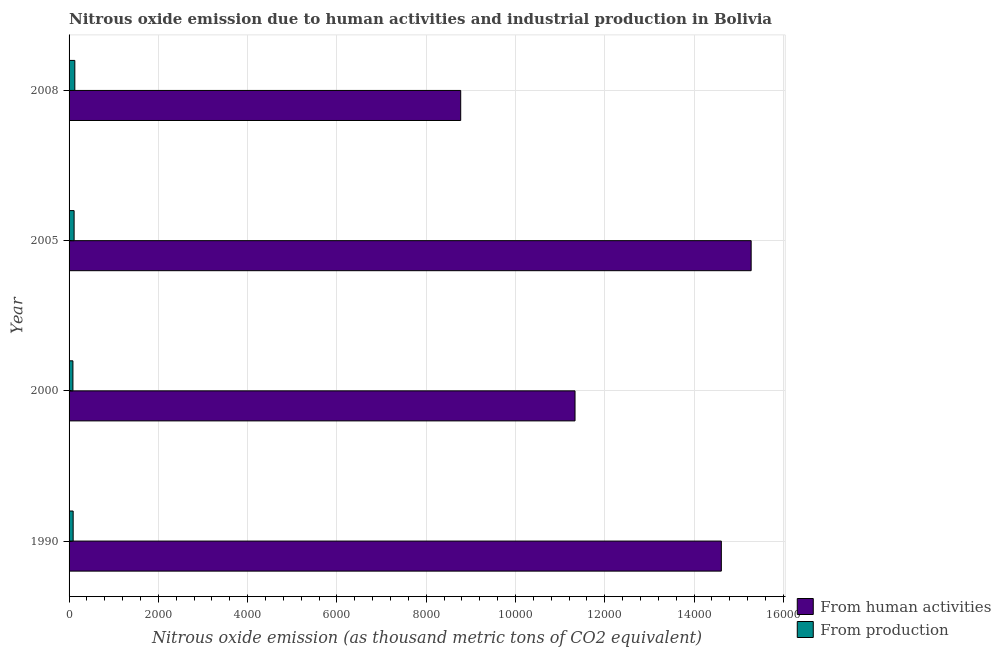How many groups of bars are there?
Give a very brief answer. 4. How many bars are there on the 2nd tick from the top?
Your answer should be compact. 2. What is the label of the 2nd group of bars from the top?
Your response must be concise. 2005. What is the amount of emissions generated from industries in 2008?
Ensure brevity in your answer.  128.9. Across all years, what is the maximum amount of emissions from human activities?
Give a very brief answer. 1.53e+04. Across all years, what is the minimum amount of emissions from human activities?
Provide a succinct answer. 8773. In which year was the amount of emissions generated from industries maximum?
Offer a terse response. 2008. In which year was the amount of emissions from human activities minimum?
Provide a succinct answer. 2008. What is the total amount of emissions from human activities in the graph?
Make the answer very short. 5.00e+04. What is the difference between the amount of emissions from human activities in 2000 and that in 2008?
Your answer should be very brief. 2561.1. What is the difference between the amount of emissions from human activities in 2008 and the amount of emissions generated from industries in 1990?
Offer a very short reply. 8681.6. What is the average amount of emissions from human activities per year?
Keep it short and to the point. 1.25e+04. In the year 2005, what is the difference between the amount of emissions from human activities and amount of emissions generated from industries?
Ensure brevity in your answer.  1.52e+04. In how many years, is the amount of emissions generated from industries greater than 14000 thousand metric tons?
Ensure brevity in your answer.  0. What is the ratio of the amount of emissions from human activities in 1990 to that in 2005?
Make the answer very short. 0.96. Is the difference between the amount of emissions from human activities in 2000 and 2005 greater than the difference between the amount of emissions generated from industries in 2000 and 2005?
Provide a succinct answer. No. What is the difference between the highest and the second highest amount of emissions generated from industries?
Ensure brevity in your answer.  16.2. What is the difference between the highest and the lowest amount of emissions from human activities?
Your answer should be very brief. 6506.5. In how many years, is the amount of emissions generated from industries greater than the average amount of emissions generated from industries taken over all years?
Ensure brevity in your answer.  2. Is the sum of the amount of emissions from human activities in 2000 and 2008 greater than the maximum amount of emissions generated from industries across all years?
Offer a terse response. Yes. What does the 2nd bar from the top in 2008 represents?
Provide a succinct answer. From human activities. What does the 1st bar from the bottom in 2000 represents?
Give a very brief answer. From human activities. Does the graph contain any zero values?
Give a very brief answer. No. What is the title of the graph?
Provide a succinct answer. Nitrous oxide emission due to human activities and industrial production in Bolivia. What is the label or title of the X-axis?
Offer a terse response. Nitrous oxide emission (as thousand metric tons of CO2 equivalent). What is the label or title of the Y-axis?
Offer a very short reply. Year. What is the Nitrous oxide emission (as thousand metric tons of CO2 equivalent) of From human activities in 1990?
Provide a succinct answer. 1.46e+04. What is the Nitrous oxide emission (as thousand metric tons of CO2 equivalent) of From production in 1990?
Offer a very short reply. 91.4. What is the Nitrous oxide emission (as thousand metric tons of CO2 equivalent) of From human activities in 2000?
Offer a very short reply. 1.13e+04. What is the Nitrous oxide emission (as thousand metric tons of CO2 equivalent) in From production in 2000?
Ensure brevity in your answer.  86.3. What is the Nitrous oxide emission (as thousand metric tons of CO2 equivalent) of From human activities in 2005?
Offer a very short reply. 1.53e+04. What is the Nitrous oxide emission (as thousand metric tons of CO2 equivalent) of From production in 2005?
Your response must be concise. 112.7. What is the Nitrous oxide emission (as thousand metric tons of CO2 equivalent) in From human activities in 2008?
Ensure brevity in your answer.  8773. What is the Nitrous oxide emission (as thousand metric tons of CO2 equivalent) in From production in 2008?
Your response must be concise. 128.9. Across all years, what is the maximum Nitrous oxide emission (as thousand metric tons of CO2 equivalent) in From human activities?
Your answer should be very brief. 1.53e+04. Across all years, what is the maximum Nitrous oxide emission (as thousand metric tons of CO2 equivalent) in From production?
Make the answer very short. 128.9. Across all years, what is the minimum Nitrous oxide emission (as thousand metric tons of CO2 equivalent) of From human activities?
Give a very brief answer. 8773. Across all years, what is the minimum Nitrous oxide emission (as thousand metric tons of CO2 equivalent) in From production?
Provide a succinct answer. 86.3. What is the total Nitrous oxide emission (as thousand metric tons of CO2 equivalent) of From human activities in the graph?
Provide a succinct answer. 5.00e+04. What is the total Nitrous oxide emission (as thousand metric tons of CO2 equivalent) of From production in the graph?
Offer a very short reply. 419.3. What is the difference between the Nitrous oxide emission (as thousand metric tons of CO2 equivalent) of From human activities in 1990 and that in 2000?
Keep it short and to the point. 3277.5. What is the difference between the Nitrous oxide emission (as thousand metric tons of CO2 equivalent) in From production in 1990 and that in 2000?
Keep it short and to the point. 5.1. What is the difference between the Nitrous oxide emission (as thousand metric tons of CO2 equivalent) of From human activities in 1990 and that in 2005?
Ensure brevity in your answer.  -667.9. What is the difference between the Nitrous oxide emission (as thousand metric tons of CO2 equivalent) of From production in 1990 and that in 2005?
Your answer should be very brief. -21.3. What is the difference between the Nitrous oxide emission (as thousand metric tons of CO2 equivalent) of From human activities in 1990 and that in 2008?
Your response must be concise. 5838.6. What is the difference between the Nitrous oxide emission (as thousand metric tons of CO2 equivalent) of From production in 1990 and that in 2008?
Give a very brief answer. -37.5. What is the difference between the Nitrous oxide emission (as thousand metric tons of CO2 equivalent) in From human activities in 2000 and that in 2005?
Your response must be concise. -3945.4. What is the difference between the Nitrous oxide emission (as thousand metric tons of CO2 equivalent) of From production in 2000 and that in 2005?
Provide a short and direct response. -26.4. What is the difference between the Nitrous oxide emission (as thousand metric tons of CO2 equivalent) of From human activities in 2000 and that in 2008?
Provide a succinct answer. 2561.1. What is the difference between the Nitrous oxide emission (as thousand metric tons of CO2 equivalent) of From production in 2000 and that in 2008?
Offer a very short reply. -42.6. What is the difference between the Nitrous oxide emission (as thousand metric tons of CO2 equivalent) in From human activities in 2005 and that in 2008?
Ensure brevity in your answer.  6506.5. What is the difference between the Nitrous oxide emission (as thousand metric tons of CO2 equivalent) in From production in 2005 and that in 2008?
Your response must be concise. -16.2. What is the difference between the Nitrous oxide emission (as thousand metric tons of CO2 equivalent) of From human activities in 1990 and the Nitrous oxide emission (as thousand metric tons of CO2 equivalent) of From production in 2000?
Offer a very short reply. 1.45e+04. What is the difference between the Nitrous oxide emission (as thousand metric tons of CO2 equivalent) in From human activities in 1990 and the Nitrous oxide emission (as thousand metric tons of CO2 equivalent) in From production in 2005?
Your answer should be very brief. 1.45e+04. What is the difference between the Nitrous oxide emission (as thousand metric tons of CO2 equivalent) of From human activities in 1990 and the Nitrous oxide emission (as thousand metric tons of CO2 equivalent) of From production in 2008?
Offer a very short reply. 1.45e+04. What is the difference between the Nitrous oxide emission (as thousand metric tons of CO2 equivalent) of From human activities in 2000 and the Nitrous oxide emission (as thousand metric tons of CO2 equivalent) of From production in 2005?
Keep it short and to the point. 1.12e+04. What is the difference between the Nitrous oxide emission (as thousand metric tons of CO2 equivalent) of From human activities in 2000 and the Nitrous oxide emission (as thousand metric tons of CO2 equivalent) of From production in 2008?
Offer a very short reply. 1.12e+04. What is the difference between the Nitrous oxide emission (as thousand metric tons of CO2 equivalent) of From human activities in 2005 and the Nitrous oxide emission (as thousand metric tons of CO2 equivalent) of From production in 2008?
Your answer should be very brief. 1.52e+04. What is the average Nitrous oxide emission (as thousand metric tons of CO2 equivalent) in From human activities per year?
Offer a terse response. 1.25e+04. What is the average Nitrous oxide emission (as thousand metric tons of CO2 equivalent) of From production per year?
Provide a succinct answer. 104.83. In the year 1990, what is the difference between the Nitrous oxide emission (as thousand metric tons of CO2 equivalent) in From human activities and Nitrous oxide emission (as thousand metric tons of CO2 equivalent) in From production?
Offer a very short reply. 1.45e+04. In the year 2000, what is the difference between the Nitrous oxide emission (as thousand metric tons of CO2 equivalent) in From human activities and Nitrous oxide emission (as thousand metric tons of CO2 equivalent) in From production?
Your answer should be compact. 1.12e+04. In the year 2005, what is the difference between the Nitrous oxide emission (as thousand metric tons of CO2 equivalent) in From human activities and Nitrous oxide emission (as thousand metric tons of CO2 equivalent) in From production?
Ensure brevity in your answer.  1.52e+04. In the year 2008, what is the difference between the Nitrous oxide emission (as thousand metric tons of CO2 equivalent) in From human activities and Nitrous oxide emission (as thousand metric tons of CO2 equivalent) in From production?
Provide a succinct answer. 8644.1. What is the ratio of the Nitrous oxide emission (as thousand metric tons of CO2 equivalent) of From human activities in 1990 to that in 2000?
Offer a very short reply. 1.29. What is the ratio of the Nitrous oxide emission (as thousand metric tons of CO2 equivalent) in From production in 1990 to that in 2000?
Keep it short and to the point. 1.06. What is the ratio of the Nitrous oxide emission (as thousand metric tons of CO2 equivalent) in From human activities in 1990 to that in 2005?
Your answer should be compact. 0.96. What is the ratio of the Nitrous oxide emission (as thousand metric tons of CO2 equivalent) of From production in 1990 to that in 2005?
Give a very brief answer. 0.81. What is the ratio of the Nitrous oxide emission (as thousand metric tons of CO2 equivalent) of From human activities in 1990 to that in 2008?
Keep it short and to the point. 1.67. What is the ratio of the Nitrous oxide emission (as thousand metric tons of CO2 equivalent) in From production in 1990 to that in 2008?
Ensure brevity in your answer.  0.71. What is the ratio of the Nitrous oxide emission (as thousand metric tons of CO2 equivalent) of From human activities in 2000 to that in 2005?
Ensure brevity in your answer.  0.74. What is the ratio of the Nitrous oxide emission (as thousand metric tons of CO2 equivalent) of From production in 2000 to that in 2005?
Provide a succinct answer. 0.77. What is the ratio of the Nitrous oxide emission (as thousand metric tons of CO2 equivalent) in From human activities in 2000 to that in 2008?
Offer a very short reply. 1.29. What is the ratio of the Nitrous oxide emission (as thousand metric tons of CO2 equivalent) in From production in 2000 to that in 2008?
Keep it short and to the point. 0.67. What is the ratio of the Nitrous oxide emission (as thousand metric tons of CO2 equivalent) of From human activities in 2005 to that in 2008?
Ensure brevity in your answer.  1.74. What is the ratio of the Nitrous oxide emission (as thousand metric tons of CO2 equivalent) in From production in 2005 to that in 2008?
Offer a very short reply. 0.87. What is the difference between the highest and the second highest Nitrous oxide emission (as thousand metric tons of CO2 equivalent) of From human activities?
Your answer should be compact. 667.9. What is the difference between the highest and the lowest Nitrous oxide emission (as thousand metric tons of CO2 equivalent) in From human activities?
Provide a succinct answer. 6506.5. What is the difference between the highest and the lowest Nitrous oxide emission (as thousand metric tons of CO2 equivalent) of From production?
Ensure brevity in your answer.  42.6. 